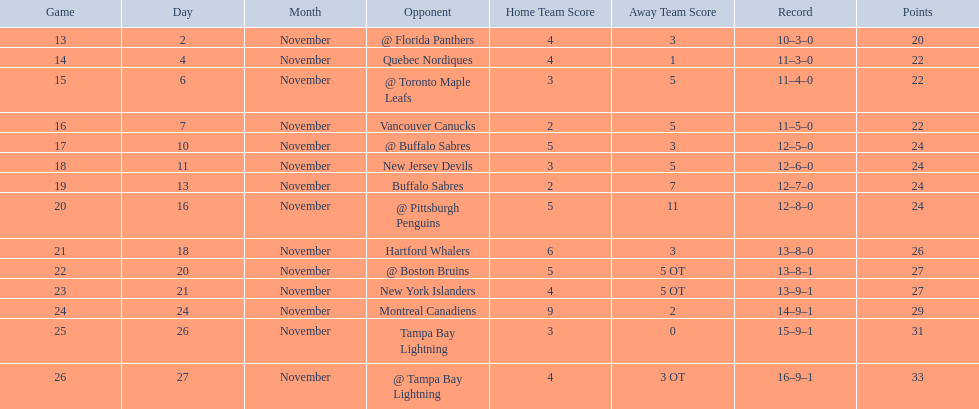Who did the philadelphia flyers play in game 17? @ Buffalo Sabres. What was the score of the november 10th game against the buffalo sabres? 5–3. Which team in the atlantic division had less points than the philadelphia flyers? Tampa Bay Lightning. 